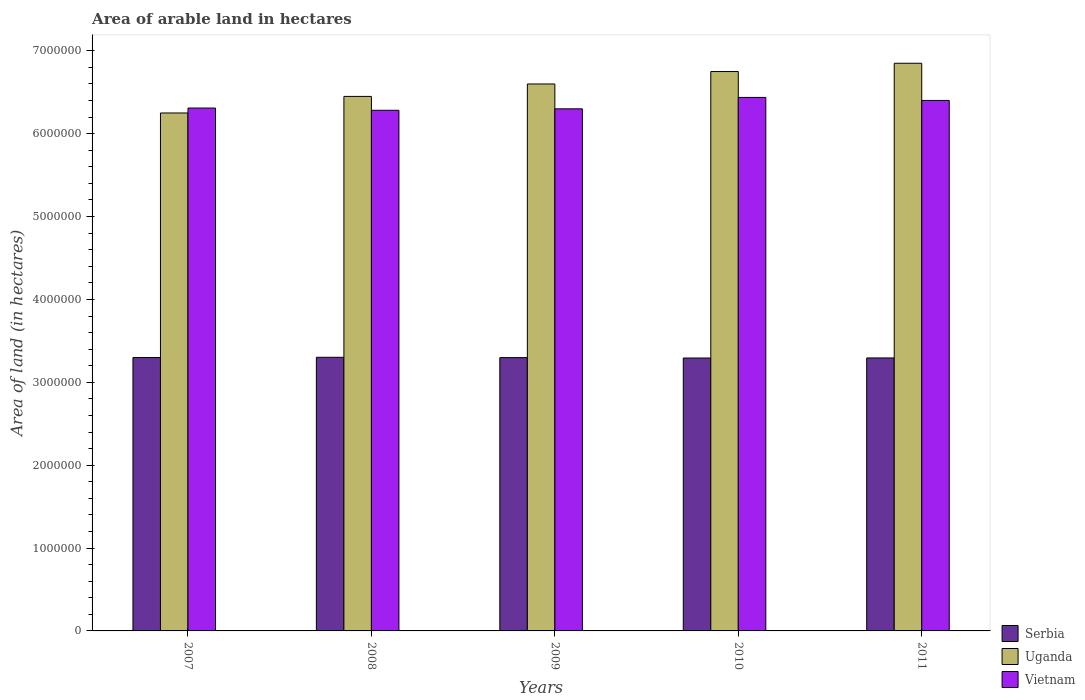How many different coloured bars are there?
Ensure brevity in your answer.  3. Are the number of bars on each tick of the X-axis equal?
Make the answer very short. Yes. What is the total arable land in Vietnam in 2009?
Keep it short and to the point. 6.30e+06. Across all years, what is the maximum total arable land in Uganda?
Your response must be concise. 6.85e+06. Across all years, what is the minimum total arable land in Serbia?
Provide a short and direct response. 3.29e+06. In which year was the total arable land in Serbia maximum?
Your response must be concise. 2008. What is the total total arable land in Uganda in the graph?
Make the answer very short. 3.29e+07. What is the difference between the total arable land in Uganda in 2007 and that in 2009?
Offer a terse response. -3.50e+05. What is the difference between the total arable land in Uganda in 2008 and the total arable land in Vietnam in 2011?
Your answer should be very brief. 4.87e+04. What is the average total arable land in Vietnam per year?
Give a very brief answer. 6.35e+06. In the year 2007, what is the difference between the total arable land in Vietnam and total arable land in Uganda?
Offer a terse response. 5.96e+04. In how many years, is the total arable land in Uganda greater than 3200000 hectares?
Provide a short and direct response. 5. What is the ratio of the total arable land in Uganda in 2008 to that in 2011?
Provide a short and direct response. 0.94. Is the total arable land in Serbia in 2009 less than that in 2010?
Provide a short and direct response. No. What is the difference between the highest and the second highest total arable land in Vietnam?
Keep it short and to the point. 3.63e+04. What is the difference between the highest and the lowest total arable land in Uganda?
Your answer should be compact. 6.00e+05. What does the 1st bar from the left in 2008 represents?
Your response must be concise. Serbia. What does the 3rd bar from the right in 2008 represents?
Your response must be concise. Serbia. Is it the case that in every year, the sum of the total arable land in Vietnam and total arable land in Serbia is greater than the total arable land in Uganda?
Ensure brevity in your answer.  Yes. How many bars are there?
Keep it short and to the point. 15. Are all the bars in the graph horizontal?
Offer a terse response. No. How many years are there in the graph?
Your response must be concise. 5. Does the graph contain grids?
Your answer should be very brief. No. Where does the legend appear in the graph?
Give a very brief answer. Bottom right. What is the title of the graph?
Offer a very short reply. Area of arable land in hectares. What is the label or title of the X-axis?
Your answer should be compact. Years. What is the label or title of the Y-axis?
Your answer should be compact. Area of land (in hectares). What is the Area of land (in hectares) in Serbia in 2007?
Keep it short and to the point. 3.30e+06. What is the Area of land (in hectares) of Uganda in 2007?
Provide a short and direct response. 6.25e+06. What is the Area of land (in hectares) in Vietnam in 2007?
Ensure brevity in your answer.  6.31e+06. What is the Area of land (in hectares) of Serbia in 2008?
Make the answer very short. 3.30e+06. What is the Area of land (in hectares) in Uganda in 2008?
Make the answer very short. 6.45e+06. What is the Area of land (in hectares) in Vietnam in 2008?
Your answer should be very brief. 6.28e+06. What is the Area of land (in hectares) in Serbia in 2009?
Make the answer very short. 3.30e+06. What is the Area of land (in hectares) of Uganda in 2009?
Provide a short and direct response. 6.60e+06. What is the Area of land (in hectares) in Vietnam in 2009?
Make the answer very short. 6.30e+06. What is the Area of land (in hectares) of Serbia in 2010?
Offer a very short reply. 3.29e+06. What is the Area of land (in hectares) of Uganda in 2010?
Make the answer very short. 6.75e+06. What is the Area of land (in hectares) in Vietnam in 2010?
Ensure brevity in your answer.  6.44e+06. What is the Area of land (in hectares) in Serbia in 2011?
Offer a very short reply. 3.29e+06. What is the Area of land (in hectares) in Uganda in 2011?
Your answer should be compact. 6.85e+06. What is the Area of land (in hectares) of Vietnam in 2011?
Your answer should be very brief. 6.40e+06. Across all years, what is the maximum Area of land (in hectares) in Serbia?
Make the answer very short. 3.30e+06. Across all years, what is the maximum Area of land (in hectares) of Uganda?
Keep it short and to the point. 6.85e+06. Across all years, what is the maximum Area of land (in hectares) of Vietnam?
Your answer should be very brief. 6.44e+06. Across all years, what is the minimum Area of land (in hectares) of Serbia?
Make the answer very short. 3.29e+06. Across all years, what is the minimum Area of land (in hectares) in Uganda?
Offer a very short reply. 6.25e+06. Across all years, what is the minimum Area of land (in hectares) in Vietnam?
Your answer should be compact. 6.28e+06. What is the total Area of land (in hectares) of Serbia in the graph?
Give a very brief answer. 1.65e+07. What is the total Area of land (in hectares) of Uganda in the graph?
Provide a short and direct response. 3.29e+07. What is the total Area of land (in hectares) in Vietnam in the graph?
Your answer should be very brief. 3.17e+07. What is the difference between the Area of land (in hectares) of Serbia in 2007 and that in 2008?
Your response must be concise. -3000. What is the difference between the Area of land (in hectares) of Uganda in 2007 and that in 2008?
Provide a succinct answer. -2.00e+05. What is the difference between the Area of land (in hectares) in Vietnam in 2007 and that in 2008?
Keep it short and to the point. 2.71e+04. What is the difference between the Area of land (in hectares) of Uganda in 2007 and that in 2009?
Your answer should be compact. -3.50e+05. What is the difference between the Area of land (in hectares) in Vietnam in 2007 and that in 2009?
Your answer should be compact. 9600. What is the difference between the Area of land (in hectares) of Serbia in 2007 and that in 2010?
Offer a very short reply. 6000. What is the difference between the Area of land (in hectares) in Uganda in 2007 and that in 2010?
Make the answer very short. -5.00e+05. What is the difference between the Area of land (in hectares) of Vietnam in 2007 and that in 2010?
Give a very brief answer. -1.28e+05. What is the difference between the Area of land (in hectares) in Uganda in 2007 and that in 2011?
Your response must be concise. -6.00e+05. What is the difference between the Area of land (in hectares) in Vietnam in 2007 and that in 2011?
Keep it short and to the point. -9.17e+04. What is the difference between the Area of land (in hectares) in Serbia in 2008 and that in 2009?
Your answer should be compact. 4000. What is the difference between the Area of land (in hectares) in Vietnam in 2008 and that in 2009?
Your response must be concise. -1.75e+04. What is the difference between the Area of land (in hectares) of Serbia in 2008 and that in 2010?
Provide a succinct answer. 9000. What is the difference between the Area of land (in hectares) of Vietnam in 2008 and that in 2010?
Your response must be concise. -1.55e+05. What is the difference between the Area of land (in hectares) of Serbia in 2008 and that in 2011?
Your answer should be very brief. 8000. What is the difference between the Area of land (in hectares) in Uganda in 2008 and that in 2011?
Your answer should be very brief. -4.00e+05. What is the difference between the Area of land (in hectares) in Vietnam in 2008 and that in 2011?
Provide a succinct answer. -1.19e+05. What is the difference between the Area of land (in hectares) in Vietnam in 2009 and that in 2010?
Your answer should be compact. -1.38e+05. What is the difference between the Area of land (in hectares) in Serbia in 2009 and that in 2011?
Provide a succinct answer. 4000. What is the difference between the Area of land (in hectares) in Vietnam in 2009 and that in 2011?
Ensure brevity in your answer.  -1.01e+05. What is the difference between the Area of land (in hectares) in Serbia in 2010 and that in 2011?
Offer a terse response. -1000. What is the difference between the Area of land (in hectares) of Vietnam in 2010 and that in 2011?
Provide a short and direct response. 3.63e+04. What is the difference between the Area of land (in hectares) of Serbia in 2007 and the Area of land (in hectares) of Uganda in 2008?
Your answer should be compact. -3.15e+06. What is the difference between the Area of land (in hectares) of Serbia in 2007 and the Area of land (in hectares) of Vietnam in 2008?
Your answer should be compact. -2.98e+06. What is the difference between the Area of land (in hectares) of Uganda in 2007 and the Area of land (in hectares) of Vietnam in 2008?
Provide a short and direct response. -3.25e+04. What is the difference between the Area of land (in hectares) of Serbia in 2007 and the Area of land (in hectares) of Uganda in 2009?
Provide a short and direct response. -3.30e+06. What is the difference between the Area of land (in hectares) in Serbia in 2007 and the Area of land (in hectares) in Vietnam in 2009?
Your answer should be compact. -3.00e+06. What is the difference between the Area of land (in hectares) in Serbia in 2007 and the Area of land (in hectares) in Uganda in 2010?
Your response must be concise. -3.45e+06. What is the difference between the Area of land (in hectares) in Serbia in 2007 and the Area of land (in hectares) in Vietnam in 2010?
Your response must be concise. -3.14e+06. What is the difference between the Area of land (in hectares) of Uganda in 2007 and the Area of land (in hectares) of Vietnam in 2010?
Your answer should be compact. -1.88e+05. What is the difference between the Area of land (in hectares) of Serbia in 2007 and the Area of land (in hectares) of Uganda in 2011?
Keep it short and to the point. -3.55e+06. What is the difference between the Area of land (in hectares) in Serbia in 2007 and the Area of land (in hectares) in Vietnam in 2011?
Offer a very short reply. -3.10e+06. What is the difference between the Area of land (in hectares) of Uganda in 2007 and the Area of land (in hectares) of Vietnam in 2011?
Your answer should be compact. -1.51e+05. What is the difference between the Area of land (in hectares) of Serbia in 2008 and the Area of land (in hectares) of Uganda in 2009?
Keep it short and to the point. -3.30e+06. What is the difference between the Area of land (in hectares) in Serbia in 2008 and the Area of land (in hectares) in Vietnam in 2009?
Your answer should be compact. -3.00e+06. What is the difference between the Area of land (in hectares) of Uganda in 2008 and the Area of land (in hectares) of Vietnam in 2009?
Your answer should be compact. 1.50e+05. What is the difference between the Area of land (in hectares) of Serbia in 2008 and the Area of land (in hectares) of Uganda in 2010?
Keep it short and to the point. -3.45e+06. What is the difference between the Area of land (in hectares) of Serbia in 2008 and the Area of land (in hectares) of Vietnam in 2010?
Ensure brevity in your answer.  -3.14e+06. What is the difference between the Area of land (in hectares) in Uganda in 2008 and the Area of land (in hectares) in Vietnam in 2010?
Your response must be concise. 1.24e+04. What is the difference between the Area of land (in hectares) of Serbia in 2008 and the Area of land (in hectares) of Uganda in 2011?
Offer a very short reply. -3.55e+06. What is the difference between the Area of land (in hectares) in Serbia in 2008 and the Area of land (in hectares) in Vietnam in 2011?
Provide a short and direct response. -3.10e+06. What is the difference between the Area of land (in hectares) in Uganda in 2008 and the Area of land (in hectares) in Vietnam in 2011?
Keep it short and to the point. 4.87e+04. What is the difference between the Area of land (in hectares) of Serbia in 2009 and the Area of land (in hectares) of Uganda in 2010?
Keep it short and to the point. -3.45e+06. What is the difference between the Area of land (in hectares) of Serbia in 2009 and the Area of land (in hectares) of Vietnam in 2010?
Keep it short and to the point. -3.14e+06. What is the difference between the Area of land (in hectares) of Uganda in 2009 and the Area of land (in hectares) of Vietnam in 2010?
Keep it short and to the point. 1.62e+05. What is the difference between the Area of land (in hectares) in Serbia in 2009 and the Area of land (in hectares) in Uganda in 2011?
Provide a succinct answer. -3.55e+06. What is the difference between the Area of land (in hectares) in Serbia in 2009 and the Area of land (in hectares) in Vietnam in 2011?
Make the answer very short. -3.10e+06. What is the difference between the Area of land (in hectares) of Uganda in 2009 and the Area of land (in hectares) of Vietnam in 2011?
Your answer should be very brief. 1.99e+05. What is the difference between the Area of land (in hectares) of Serbia in 2010 and the Area of land (in hectares) of Uganda in 2011?
Your response must be concise. -3.56e+06. What is the difference between the Area of land (in hectares) of Serbia in 2010 and the Area of land (in hectares) of Vietnam in 2011?
Provide a succinct answer. -3.11e+06. What is the difference between the Area of land (in hectares) in Uganda in 2010 and the Area of land (in hectares) in Vietnam in 2011?
Provide a short and direct response. 3.49e+05. What is the average Area of land (in hectares) of Serbia per year?
Keep it short and to the point. 3.30e+06. What is the average Area of land (in hectares) of Uganda per year?
Make the answer very short. 6.58e+06. What is the average Area of land (in hectares) of Vietnam per year?
Your answer should be very brief. 6.35e+06. In the year 2007, what is the difference between the Area of land (in hectares) in Serbia and Area of land (in hectares) in Uganda?
Your answer should be compact. -2.95e+06. In the year 2007, what is the difference between the Area of land (in hectares) of Serbia and Area of land (in hectares) of Vietnam?
Make the answer very short. -3.01e+06. In the year 2007, what is the difference between the Area of land (in hectares) in Uganda and Area of land (in hectares) in Vietnam?
Your answer should be compact. -5.96e+04. In the year 2008, what is the difference between the Area of land (in hectares) of Serbia and Area of land (in hectares) of Uganda?
Your answer should be very brief. -3.15e+06. In the year 2008, what is the difference between the Area of land (in hectares) in Serbia and Area of land (in hectares) in Vietnam?
Offer a very short reply. -2.98e+06. In the year 2008, what is the difference between the Area of land (in hectares) in Uganda and Area of land (in hectares) in Vietnam?
Make the answer very short. 1.68e+05. In the year 2009, what is the difference between the Area of land (in hectares) of Serbia and Area of land (in hectares) of Uganda?
Ensure brevity in your answer.  -3.30e+06. In the year 2009, what is the difference between the Area of land (in hectares) of Serbia and Area of land (in hectares) of Vietnam?
Provide a succinct answer. -3.00e+06. In the year 2009, what is the difference between the Area of land (in hectares) of Uganda and Area of land (in hectares) of Vietnam?
Your answer should be very brief. 3.00e+05. In the year 2010, what is the difference between the Area of land (in hectares) of Serbia and Area of land (in hectares) of Uganda?
Ensure brevity in your answer.  -3.46e+06. In the year 2010, what is the difference between the Area of land (in hectares) of Serbia and Area of land (in hectares) of Vietnam?
Provide a short and direct response. -3.14e+06. In the year 2010, what is the difference between the Area of land (in hectares) in Uganda and Area of land (in hectares) in Vietnam?
Provide a succinct answer. 3.12e+05. In the year 2011, what is the difference between the Area of land (in hectares) in Serbia and Area of land (in hectares) in Uganda?
Make the answer very short. -3.56e+06. In the year 2011, what is the difference between the Area of land (in hectares) in Serbia and Area of land (in hectares) in Vietnam?
Provide a short and direct response. -3.11e+06. In the year 2011, what is the difference between the Area of land (in hectares) of Uganda and Area of land (in hectares) of Vietnam?
Provide a short and direct response. 4.49e+05. What is the ratio of the Area of land (in hectares) of Serbia in 2007 to that in 2008?
Provide a short and direct response. 1. What is the ratio of the Area of land (in hectares) in Vietnam in 2007 to that in 2008?
Ensure brevity in your answer.  1. What is the ratio of the Area of land (in hectares) of Serbia in 2007 to that in 2009?
Your response must be concise. 1. What is the ratio of the Area of land (in hectares) of Uganda in 2007 to that in 2009?
Ensure brevity in your answer.  0.95. What is the ratio of the Area of land (in hectares) in Uganda in 2007 to that in 2010?
Your answer should be compact. 0.93. What is the ratio of the Area of land (in hectares) of Vietnam in 2007 to that in 2010?
Offer a terse response. 0.98. What is the ratio of the Area of land (in hectares) in Uganda in 2007 to that in 2011?
Your answer should be compact. 0.91. What is the ratio of the Area of land (in hectares) in Vietnam in 2007 to that in 2011?
Provide a short and direct response. 0.99. What is the ratio of the Area of land (in hectares) in Serbia in 2008 to that in 2009?
Give a very brief answer. 1. What is the ratio of the Area of land (in hectares) of Uganda in 2008 to that in 2009?
Provide a short and direct response. 0.98. What is the ratio of the Area of land (in hectares) in Serbia in 2008 to that in 2010?
Ensure brevity in your answer.  1. What is the ratio of the Area of land (in hectares) of Uganda in 2008 to that in 2010?
Offer a very short reply. 0.96. What is the ratio of the Area of land (in hectares) in Vietnam in 2008 to that in 2010?
Make the answer very short. 0.98. What is the ratio of the Area of land (in hectares) of Uganda in 2008 to that in 2011?
Offer a very short reply. 0.94. What is the ratio of the Area of land (in hectares) of Vietnam in 2008 to that in 2011?
Make the answer very short. 0.98. What is the ratio of the Area of land (in hectares) in Uganda in 2009 to that in 2010?
Your answer should be compact. 0.98. What is the ratio of the Area of land (in hectares) in Vietnam in 2009 to that in 2010?
Make the answer very short. 0.98. What is the ratio of the Area of land (in hectares) in Uganda in 2009 to that in 2011?
Your answer should be compact. 0.96. What is the ratio of the Area of land (in hectares) of Vietnam in 2009 to that in 2011?
Provide a short and direct response. 0.98. What is the ratio of the Area of land (in hectares) of Serbia in 2010 to that in 2011?
Your answer should be compact. 1. What is the ratio of the Area of land (in hectares) of Uganda in 2010 to that in 2011?
Ensure brevity in your answer.  0.99. What is the ratio of the Area of land (in hectares) of Vietnam in 2010 to that in 2011?
Ensure brevity in your answer.  1.01. What is the difference between the highest and the second highest Area of land (in hectares) in Serbia?
Keep it short and to the point. 3000. What is the difference between the highest and the second highest Area of land (in hectares) of Uganda?
Ensure brevity in your answer.  1.00e+05. What is the difference between the highest and the second highest Area of land (in hectares) in Vietnam?
Provide a short and direct response. 3.63e+04. What is the difference between the highest and the lowest Area of land (in hectares) in Serbia?
Give a very brief answer. 9000. What is the difference between the highest and the lowest Area of land (in hectares) in Vietnam?
Give a very brief answer. 1.55e+05. 